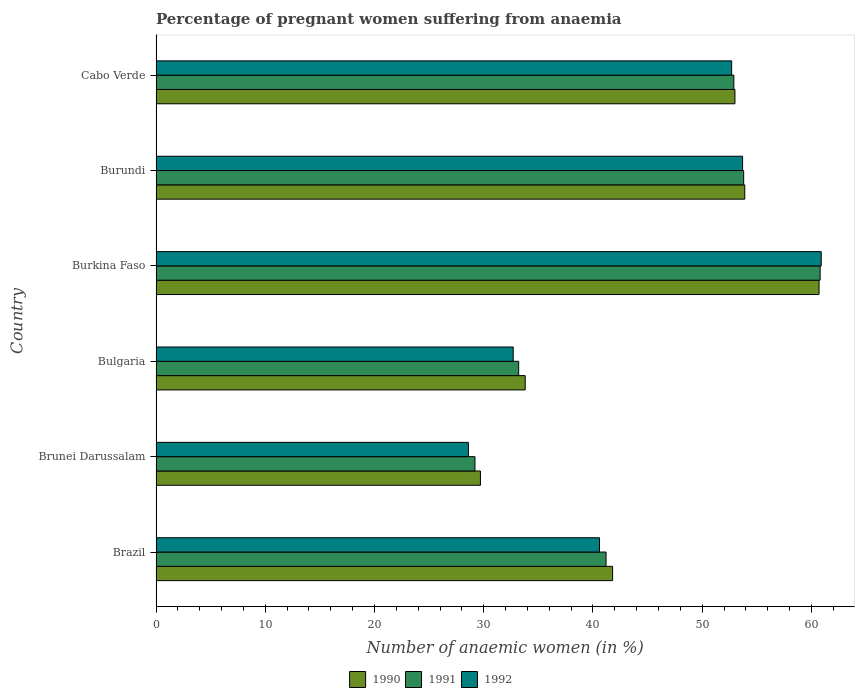How many different coloured bars are there?
Keep it short and to the point. 3. Are the number of bars per tick equal to the number of legend labels?
Give a very brief answer. Yes. Are the number of bars on each tick of the Y-axis equal?
Provide a succinct answer. Yes. What is the label of the 6th group of bars from the top?
Offer a terse response. Brazil. In how many cases, is the number of bars for a given country not equal to the number of legend labels?
Offer a very short reply. 0. What is the number of anaemic women in 1991 in Burundi?
Ensure brevity in your answer.  53.8. Across all countries, what is the maximum number of anaemic women in 1992?
Provide a succinct answer. 60.9. Across all countries, what is the minimum number of anaemic women in 1991?
Your answer should be very brief. 29.2. In which country was the number of anaemic women in 1992 maximum?
Give a very brief answer. Burkina Faso. In which country was the number of anaemic women in 1990 minimum?
Make the answer very short. Brunei Darussalam. What is the total number of anaemic women in 1990 in the graph?
Ensure brevity in your answer.  272.9. What is the difference between the number of anaemic women in 1992 in Brunei Darussalam and that in Burkina Faso?
Offer a terse response. -32.3. What is the difference between the number of anaemic women in 1990 in Brunei Darussalam and the number of anaemic women in 1992 in Brazil?
Keep it short and to the point. -10.9. What is the average number of anaemic women in 1991 per country?
Your answer should be very brief. 45.18. What is the difference between the number of anaemic women in 1990 and number of anaemic women in 1992 in Brunei Darussalam?
Give a very brief answer. 1.1. What is the ratio of the number of anaemic women in 1991 in Bulgaria to that in Cabo Verde?
Provide a short and direct response. 0.63. Is the difference between the number of anaemic women in 1990 in Brunei Darussalam and Burkina Faso greater than the difference between the number of anaemic women in 1992 in Brunei Darussalam and Burkina Faso?
Provide a short and direct response. Yes. What is the difference between the highest and the second highest number of anaemic women in 1992?
Ensure brevity in your answer.  7.2. What is the difference between the highest and the lowest number of anaemic women in 1990?
Provide a short and direct response. 31. In how many countries, is the number of anaemic women in 1990 greater than the average number of anaemic women in 1990 taken over all countries?
Your response must be concise. 3. Is the sum of the number of anaemic women in 1992 in Brazil and Burundi greater than the maximum number of anaemic women in 1991 across all countries?
Make the answer very short. Yes. What does the 1st bar from the top in Brunei Darussalam represents?
Give a very brief answer. 1992. What does the 3rd bar from the bottom in Burundi represents?
Make the answer very short. 1992. How many bars are there?
Keep it short and to the point. 18. How many countries are there in the graph?
Make the answer very short. 6. What is the difference between two consecutive major ticks on the X-axis?
Offer a very short reply. 10. Does the graph contain grids?
Provide a short and direct response. No. Where does the legend appear in the graph?
Ensure brevity in your answer.  Bottom center. How many legend labels are there?
Provide a succinct answer. 3. How are the legend labels stacked?
Ensure brevity in your answer.  Horizontal. What is the title of the graph?
Provide a succinct answer. Percentage of pregnant women suffering from anaemia. Does "1999" appear as one of the legend labels in the graph?
Your answer should be compact. No. What is the label or title of the X-axis?
Provide a short and direct response. Number of anaemic women (in %). What is the Number of anaemic women (in %) of 1990 in Brazil?
Your answer should be compact. 41.8. What is the Number of anaemic women (in %) of 1991 in Brazil?
Ensure brevity in your answer.  41.2. What is the Number of anaemic women (in %) in 1992 in Brazil?
Provide a succinct answer. 40.6. What is the Number of anaemic women (in %) in 1990 in Brunei Darussalam?
Make the answer very short. 29.7. What is the Number of anaemic women (in %) in 1991 in Brunei Darussalam?
Give a very brief answer. 29.2. What is the Number of anaemic women (in %) in 1992 in Brunei Darussalam?
Your response must be concise. 28.6. What is the Number of anaemic women (in %) in 1990 in Bulgaria?
Provide a short and direct response. 33.8. What is the Number of anaemic women (in %) of 1991 in Bulgaria?
Offer a very short reply. 33.2. What is the Number of anaemic women (in %) in 1992 in Bulgaria?
Your response must be concise. 32.7. What is the Number of anaemic women (in %) in 1990 in Burkina Faso?
Your answer should be compact. 60.7. What is the Number of anaemic women (in %) of 1991 in Burkina Faso?
Your answer should be compact. 60.8. What is the Number of anaemic women (in %) of 1992 in Burkina Faso?
Provide a short and direct response. 60.9. What is the Number of anaemic women (in %) of 1990 in Burundi?
Provide a short and direct response. 53.9. What is the Number of anaemic women (in %) of 1991 in Burundi?
Offer a very short reply. 53.8. What is the Number of anaemic women (in %) of 1992 in Burundi?
Provide a short and direct response. 53.7. What is the Number of anaemic women (in %) in 1990 in Cabo Verde?
Provide a succinct answer. 53. What is the Number of anaemic women (in %) of 1991 in Cabo Verde?
Make the answer very short. 52.9. What is the Number of anaemic women (in %) of 1992 in Cabo Verde?
Offer a terse response. 52.7. Across all countries, what is the maximum Number of anaemic women (in %) in 1990?
Your answer should be very brief. 60.7. Across all countries, what is the maximum Number of anaemic women (in %) of 1991?
Offer a terse response. 60.8. Across all countries, what is the maximum Number of anaemic women (in %) of 1992?
Your response must be concise. 60.9. Across all countries, what is the minimum Number of anaemic women (in %) of 1990?
Give a very brief answer. 29.7. Across all countries, what is the minimum Number of anaemic women (in %) of 1991?
Make the answer very short. 29.2. Across all countries, what is the minimum Number of anaemic women (in %) of 1992?
Offer a very short reply. 28.6. What is the total Number of anaemic women (in %) in 1990 in the graph?
Keep it short and to the point. 272.9. What is the total Number of anaemic women (in %) of 1991 in the graph?
Give a very brief answer. 271.1. What is the total Number of anaemic women (in %) in 1992 in the graph?
Offer a terse response. 269.2. What is the difference between the Number of anaemic women (in %) in 1991 in Brazil and that in Brunei Darussalam?
Offer a terse response. 12. What is the difference between the Number of anaemic women (in %) of 1992 in Brazil and that in Brunei Darussalam?
Ensure brevity in your answer.  12. What is the difference between the Number of anaemic women (in %) of 1991 in Brazil and that in Bulgaria?
Keep it short and to the point. 8. What is the difference between the Number of anaemic women (in %) in 1992 in Brazil and that in Bulgaria?
Your response must be concise. 7.9. What is the difference between the Number of anaemic women (in %) in 1990 in Brazil and that in Burkina Faso?
Ensure brevity in your answer.  -18.9. What is the difference between the Number of anaemic women (in %) of 1991 in Brazil and that in Burkina Faso?
Provide a succinct answer. -19.6. What is the difference between the Number of anaemic women (in %) in 1992 in Brazil and that in Burkina Faso?
Offer a very short reply. -20.3. What is the difference between the Number of anaemic women (in %) of 1991 in Brazil and that in Cabo Verde?
Make the answer very short. -11.7. What is the difference between the Number of anaemic women (in %) of 1990 in Brunei Darussalam and that in Burkina Faso?
Offer a terse response. -31. What is the difference between the Number of anaemic women (in %) of 1991 in Brunei Darussalam and that in Burkina Faso?
Offer a terse response. -31.6. What is the difference between the Number of anaemic women (in %) in 1992 in Brunei Darussalam and that in Burkina Faso?
Give a very brief answer. -32.3. What is the difference between the Number of anaemic women (in %) in 1990 in Brunei Darussalam and that in Burundi?
Your answer should be compact. -24.2. What is the difference between the Number of anaemic women (in %) of 1991 in Brunei Darussalam and that in Burundi?
Give a very brief answer. -24.6. What is the difference between the Number of anaemic women (in %) in 1992 in Brunei Darussalam and that in Burundi?
Your answer should be compact. -25.1. What is the difference between the Number of anaemic women (in %) of 1990 in Brunei Darussalam and that in Cabo Verde?
Provide a succinct answer. -23.3. What is the difference between the Number of anaemic women (in %) of 1991 in Brunei Darussalam and that in Cabo Verde?
Your response must be concise. -23.7. What is the difference between the Number of anaemic women (in %) in 1992 in Brunei Darussalam and that in Cabo Verde?
Your response must be concise. -24.1. What is the difference between the Number of anaemic women (in %) of 1990 in Bulgaria and that in Burkina Faso?
Give a very brief answer. -26.9. What is the difference between the Number of anaemic women (in %) of 1991 in Bulgaria and that in Burkina Faso?
Provide a succinct answer. -27.6. What is the difference between the Number of anaemic women (in %) of 1992 in Bulgaria and that in Burkina Faso?
Your response must be concise. -28.2. What is the difference between the Number of anaemic women (in %) in 1990 in Bulgaria and that in Burundi?
Your answer should be very brief. -20.1. What is the difference between the Number of anaemic women (in %) in 1991 in Bulgaria and that in Burundi?
Offer a terse response. -20.6. What is the difference between the Number of anaemic women (in %) in 1990 in Bulgaria and that in Cabo Verde?
Provide a succinct answer. -19.2. What is the difference between the Number of anaemic women (in %) of 1991 in Bulgaria and that in Cabo Verde?
Your answer should be very brief. -19.7. What is the difference between the Number of anaemic women (in %) in 1992 in Bulgaria and that in Cabo Verde?
Your answer should be very brief. -20. What is the difference between the Number of anaemic women (in %) of 1990 in Burkina Faso and that in Burundi?
Give a very brief answer. 6.8. What is the difference between the Number of anaemic women (in %) in 1992 in Burkina Faso and that in Burundi?
Your answer should be compact. 7.2. What is the difference between the Number of anaemic women (in %) in 1990 in Burkina Faso and that in Cabo Verde?
Make the answer very short. 7.7. What is the difference between the Number of anaemic women (in %) in 1992 in Burkina Faso and that in Cabo Verde?
Your answer should be compact. 8.2. What is the difference between the Number of anaemic women (in %) of 1990 in Burundi and that in Cabo Verde?
Keep it short and to the point. 0.9. What is the difference between the Number of anaemic women (in %) of 1991 in Burundi and that in Cabo Verde?
Keep it short and to the point. 0.9. What is the difference between the Number of anaemic women (in %) in 1992 in Burundi and that in Cabo Verde?
Your answer should be compact. 1. What is the difference between the Number of anaemic women (in %) in 1990 in Brazil and the Number of anaemic women (in %) in 1991 in Brunei Darussalam?
Make the answer very short. 12.6. What is the difference between the Number of anaemic women (in %) in 1990 in Brazil and the Number of anaemic women (in %) in 1992 in Brunei Darussalam?
Provide a short and direct response. 13.2. What is the difference between the Number of anaemic women (in %) in 1991 in Brazil and the Number of anaemic women (in %) in 1992 in Brunei Darussalam?
Ensure brevity in your answer.  12.6. What is the difference between the Number of anaemic women (in %) in 1990 in Brazil and the Number of anaemic women (in %) in 1991 in Bulgaria?
Ensure brevity in your answer.  8.6. What is the difference between the Number of anaemic women (in %) in 1990 in Brazil and the Number of anaemic women (in %) in 1992 in Burkina Faso?
Provide a short and direct response. -19.1. What is the difference between the Number of anaemic women (in %) in 1991 in Brazil and the Number of anaemic women (in %) in 1992 in Burkina Faso?
Keep it short and to the point. -19.7. What is the difference between the Number of anaemic women (in %) in 1990 in Brazil and the Number of anaemic women (in %) in 1991 in Burundi?
Ensure brevity in your answer.  -12. What is the difference between the Number of anaemic women (in %) of 1990 in Brazil and the Number of anaemic women (in %) of 1992 in Burundi?
Give a very brief answer. -11.9. What is the difference between the Number of anaemic women (in %) in 1991 in Brazil and the Number of anaemic women (in %) in 1992 in Burundi?
Ensure brevity in your answer.  -12.5. What is the difference between the Number of anaemic women (in %) of 1990 in Brunei Darussalam and the Number of anaemic women (in %) of 1992 in Bulgaria?
Keep it short and to the point. -3. What is the difference between the Number of anaemic women (in %) of 1990 in Brunei Darussalam and the Number of anaemic women (in %) of 1991 in Burkina Faso?
Keep it short and to the point. -31.1. What is the difference between the Number of anaemic women (in %) of 1990 in Brunei Darussalam and the Number of anaemic women (in %) of 1992 in Burkina Faso?
Your answer should be compact. -31.2. What is the difference between the Number of anaemic women (in %) of 1991 in Brunei Darussalam and the Number of anaemic women (in %) of 1992 in Burkina Faso?
Keep it short and to the point. -31.7. What is the difference between the Number of anaemic women (in %) in 1990 in Brunei Darussalam and the Number of anaemic women (in %) in 1991 in Burundi?
Your answer should be very brief. -24.1. What is the difference between the Number of anaemic women (in %) in 1991 in Brunei Darussalam and the Number of anaemic women (in %) in 1992 in Burundi?
Give a very brief answer. -24.5. What is the difference between the Number of anaemic women (in %) of 1990 in Brunei Darussalam and the Number of anaemic women (in %) of 1991 in Cabo Verde?
Your answer should be compact. -23.2. What is the difference between the Number of anaemic women (in %) of 1991 in Brunei Darussalam and the Number of anaemic women (in %) of 1992 in Cabo Verde?
Make the answer very short. -23.5. What is the difference between the Number of anaemic women (in %) of 1990 in Bulgaria and the Number of anaemic women (in %) of 1992 in Burkina Faso?
Your answer should be compact. -27.1. What is the difference between the Number of anaemic women (in %) of 1991 in Bulgaria and the Number of anaemic women (in %) of 1992 in Burkina Faso?
Offer a very short reply. -27.7. What is the difference between the Number of anaemic women (in %) of 1990 in Bulgaria and the Number of anaemic women (in %) of 1992 in Burundi?
Your response must be concise. -19.9. What is the difference between the Number of anaemic women (in %) in 1991 in Bulgaria and the Number of anaemic women (in %) in 1992 in Burundi?
Make the answer very short. -20.5. What is the difference between the Number of anaemic women (in %) in 1990 in Bulgaria and the Number of anaemic women (in %) in 1991 in Cabo Verde?
Your answer should be very brief. -19.1. What is the difference between the Number of anaemic women (in %) in 1990 in Bulgaria and the Number of anaemic women (in %) in 1992 in Cabo Verde?
Give a very brief answer. -18.9. What is the difference between the Number of anaemic women (in %) of 1991 in Bulgaria and the Number of anaemic women (in %) of 1992 in Cabo Verde?
Ensure brevity in your answer.  -19.5. What is the difference between the Number of anaemic women (in %) in 1991 in Burkina Faso and the Number of anaemic women (in %) in 1992 in Burundi?
Your answer should be compact. 7.1. What is the difference between the Number of anaemic women (in %) of 1990 in Burkina Faso and the Number of anaemic women (in %) of 1991 in Cabo Verde?
Your response must be concise. 7.8. What is the difference between the Number of anaemic women (in %) in 1991 in Burkina Faso and the Number of anaemic women (in %) in 1992 in Cabo Verde?
Your answer should be compact. 8.1. What is the difference between the Number of anaemic women (in %) of 1990 in Burundi and the Number of anaemic women (in %) of 1991 in Cabo Verde?
Offer a terse response. 1. What is the average Number of anaemic women (in %) in 1990 per country?
Keep it short and to the point. 45.48. What is the average Number of anaemic women (in %) of 1991 per country?
Your answer should be very brief. 45.18. What is the average Number of anaemic women (in %) of 1992 per country?
Your response must be concise. 44.87. What is the difference between the Number of anaemic women (in %) of 1990 and Number of anaemic women (in %) of 1992 in Brazil?
Ensure brevity in your answer.  1.2. What is the difference between the Number of anaemic women (in %) of 1990 and Number of anaemic women (in %) of 1992 in Brunei Darussalam?
Your response must be concise. 1.1. What is the difference between the Number of anaemic women (in %) of 1991 and Number of anaemic women (in %) of 1992 in Bulgaria?
Make the answer very short. 0.5. What is the difference between the Number of anaemic women (in %) of 1990 and Number of anaemic women (in %) of 1992 in Burkina Faso?
Offer a terse response. -0.2. What is the difference between the Number of anaemic women (in %) in 1991 and Number of anaemic women (in %) in 1992 in Burkina Faso?
Give a very brief answer. -0.1. What is the difference between the Number of anaemic women (in %) in 1990 and Number of anaemic women (in %) in 1991 in Burundi?
Provide a succinct answer. 0.1. What is the difference between the Number of anaemic women (in %) of 1990 and Number of anaemic women (in %) of 1992 in Burundi?
Ensure brevity in your answer.  0.2. What is the difference between the Number of anaemic women (in %) of 1990 and Number of anaemic women (in %) of 1992 in Cabo Verde?
Give a very brief answer. 0.3. What is the difference between the Number of anaemic women (in %) in 1991 and Number of anaemic women (in %) in 1992 in Cabo Verde?
Provide a succinct answer. 0.2. What is the ratio of the Number of anaemic women (in %) in 1990 in Brazil to that in Brunei Darussalam?
Offer a very short reply. 1.41. What is the ratio of the Number of anaemic women (in %) in 1991 in Brazil to that in Brunei Darussalam?
Your answer should be very brief. 1.41. What is the ratio of the Number of anaemic women (in %) of 1992 in Brazil to that in Brunei Darussalam?
Your answer should be compact. 1.42. What is the ratio of the Number of anaemic women (in %) in 1990 in Brazil to that in Bulgaria?
Provide a succinct answer. 1.24. What is the ratio of the Number of anaemic women (in %) of 1991 in Brazil to that in Bulgaria?
Offer a terse response. 1.24. What is the ratio of the Number of anaemic women (in %) of 1992 in Brazil to that in Bulgaria?
Provide a short and direct response. 1.24. What is the ratio of the Number of anaemic women (in %) in 1990 in Brazil to that in Burkina Faso?
Offer a terse response. 0.69. What is the ratio of the Number of anaemic women (in %) of 1991 in Brazil to that in Burkina Faso?
Keep it short and to the point. 0.68. What is the ratio of the Number of anaemic women (in %) of 1992 in Brazil to that in Burkina Faso?
Make the answer very short. 0.67. What is the ratio of the Number of anaemic women (in %) in 1990 in Brazil to that in Burundi?
Make the answer very short. 0.78. What is the ratio of the Number of anaemic women (in %) of 1991 in Brazil to that in Burundi?
Ensure brevity in your answer.  0.77. What is the ratio of the Number of anaemic women (in %) of 1992 in Brazil to that in Burundi?
Give a very brief answer. 0.76. What is the ratio of the Number of anaemic women (in %) of 1990 in Brazil to that in Cabo Verde?
Offer a terse response. 0.79. What is the ratio of the Number of anaemic women (in %) of 1991 in Brazil to that in Cabo Verde?
Keep it short and to the point. 0.78. What is the ratio of the Number of anaemic women (in %) of 1992 in Brazil to that in Cabo Verde?
Your answer should be very brief. 0.77. What is the ratio of the Number of anaemic women (in %) in 1990 in Brunei Darussalam to that in Bulgaria?
Provide a short and direct response. 0.88. What is the ratio of the Number of anaemic women (in %) of 1991 in Brunei Darussalam to that in Bulgaria?
Keep it short and to the point. 0.88. What is the ratio of the Number of anaemic women (in %) of 1992 in Brunei Darussalam to that in Bulgaria?
Offer a terse response. 0.87. What is the ratio of the Number of anaemic women (in %) of 1990 in Brunei Darussalam to that in Burkina Faso?
Your answer should be compact. 0.49. What is the ratio of the Number of anaemic women (in %) of 1991 in Brunei Darussalam to that in Burkina Faso?
Offer a very short reply. 0.48. What is the ratio of the Number of anaemic women (in %) in 1992 in Brunei Darussalam to that in Burkina Faso?
Give a very brief answer. 0.47. What is the ratio of the Number of anaemic women (in %) of 1990 in Brunei Darussalam to that in Burundi?
Offer a terse response. 0.55. What is the ratio of the Number of anaemic women (in %) in 1991 in Brunei Darussalam to that in Burundi?
Give a very brief answer. 0.54. What is the ratio of the Number of anaemic women (in %) in 1992 in Brunei Darussalam to that in Burundi?
Offer a terse response. 0.53. What is the ratio of the Number of anaemic women (in %) of 1990 in Brunei Darussalam to that in Cabo Verde?
Provide a short and direct response. 0.56. What is the ratio of the Number of anaemic women (in %) of 1991 in Brunei Darussalam to that in Cabo Verde?
Make the answer very short. 0.55. What is the ratio of the Number of anaemic women (in %) in 1992 in Brunei Darussalam to that in Cabo Verde?
Your response must be concise. 0.54. What is the ratio of the Number of anaemic women (in %) of 1990 in Bulgaria to that in Burkina Faso?
Offer a terse response. 0.56. What is the ratio of the Number of anaemic women (in %) of 1991 in Bulgaria to that in Burkina Faso?
Your response must be concise. 0.55. What is the ratio of the Number of anaemic women (in %) in 1992 in Bulgaria to that in Burkina Faso?
Provide a short and direct response. 0.54. What is the ratio of the Number of anaemic women (in %) of 1990 in Bulgaria to that in Burundi?
Your answer should be compact. 0.63. What is the ratio of the Number of anaemic women (in %) in 1991 in Bulgaria to that in Burundi?
Offer a terse response. 0.62. What is the ratio of the Number of anaemic women (in %) of 1992 in Bulgaria to that in Burundi?
Your response must be concise. 0.61. What is the ratio of the Number of anaemic women (in %) of 1990 in Bulgaria to that in Cabo Verde?
Your answer should be compact. 0.64. What is the ratio of the Number of anaemic women (in %) of 1991 in Bulgaria to that in Cabo Verde?
Give a very brief answer. 0.63. What is the ratio of the Number of anaemic women (in %) in 1992 in Bulgaria to that in Cabo Verde?
Make the answer very short. 0.62. What is the ratio of the Number of anaemic women (in %) in 1990 in Burkina Faso to that in Burundi?
Make the answer very short. 1.13. What is the ratio of the Number of anaemic women (in %) of 1991 in Burkina Faso to that in Burundi?
Ensure brevity in your answer.  1.13. What is the ratio of the Number of anaemic women (in %) of 1992 in Burkina Faso to that in Burundi?
Make the answer very short. 1.13. What is the ratio of the Number of anaemic women (in %) of 1990 in Burkina Faso to that in Cabo Verde?
Make the answer very short. 1.15. What is the ratio of the Number of anaemic women (in %) of 1991 in Burkina Faso to that in Cabo Verde?
Provide a succinct answer. 1.15. What is the ratio of the Number of anaemic women (in %) of 1992 in Burkina Faso to that in Cabo Verde?
Keep it short and to the point. 1.16. What is the ratio of the Number of anaemic women (in %) of 1991 in Burundi to that in Cabo Verde?
Give a very brief answer. 1.02. What is the difference between the highest and the second highest Number of anaemic women (in %) in 1991?
Provide a short and direct response. 7. What is the difference between the highest and the second highest Number of anaemic women (in %) of 1992?
Offer a terse response. 7.2. What is the difference between the highest and the lowest Number of anaemic women (in %) in 1990?
Your response must be concise. 31. What is the difference between the highest and the lowest Number of anaemic women (in %) of 1991?
Ensure brevity in your answer.  31.6. What is the difference between the highest and the lowest Number of anaemic women (in %) of 1992?
Keep it short and to the point. 32.3. 